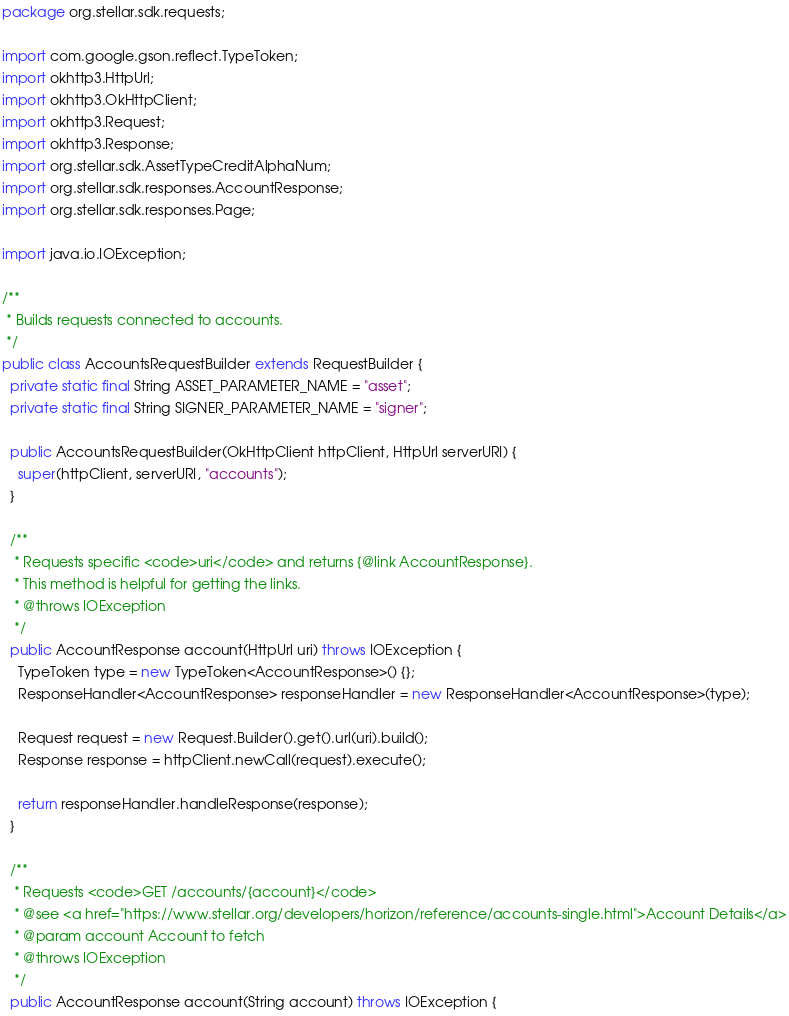<code> <loc_0><loc_0><loc_500><loc_500><_Java_>package org.stellar.sdk.requests;

import com.google.gson.reflect.TypeToken;
import okhttp3.HttpUrl;
import okhttp3.OkHttpClient;
import okhttp3.Request;
import okhttp3.Response;
import org.stellar.sdk.AssetTypeCreditAlphaNum;
import org.stellar.sdk.responses.AccountResponse;
import org.stellar.sdk.responses.Page;

import java.io.IOException;

/**
 * Builds requests connected to accounts.
 */
public class AccountsRequestBuilder extends RequestBuilder {
  private static final String ASSET_PARAMETER_NAME = "asset";
  private static final String SIGNER_PARAMETER_NAME = "signer";

  public AccountsRequestBuilder(OkHttpClient httpClient, HttpUrl serverURI) {
    super(httpClient, serverURI, "accounts");
  }

  /**
   * Requests specific <code>uri</code> and returns {@link AccountResponse}.
   * This method is helpful for getting the links.
   * @throws IOException
   */
  public AccountResponse account(HttpUrl uri) throws IOException {
    TypeToken type = new TypeToken<AccountResponse>() {};
    ResponseHandler<AccountResponse> responseHandler = new ResponseHandler<AccountResponse>(type);

    Request request = new Request.Builder().get().url(uri).build();
    Response response = httpClient.newCall(request).execute();

    return responseHandler.handleResponse(response);
  }

  /**
   * Requests <code>GET /accounts/{account}</code>
   * @see <a href="https://www.stellar.org/developers/horizon/reference/accounts-single.html">Account Details</a>
   * @param account Account to fetch
   * @throws IOException
   */
  public AccountResponse account(String account) throws IOException {</code> 